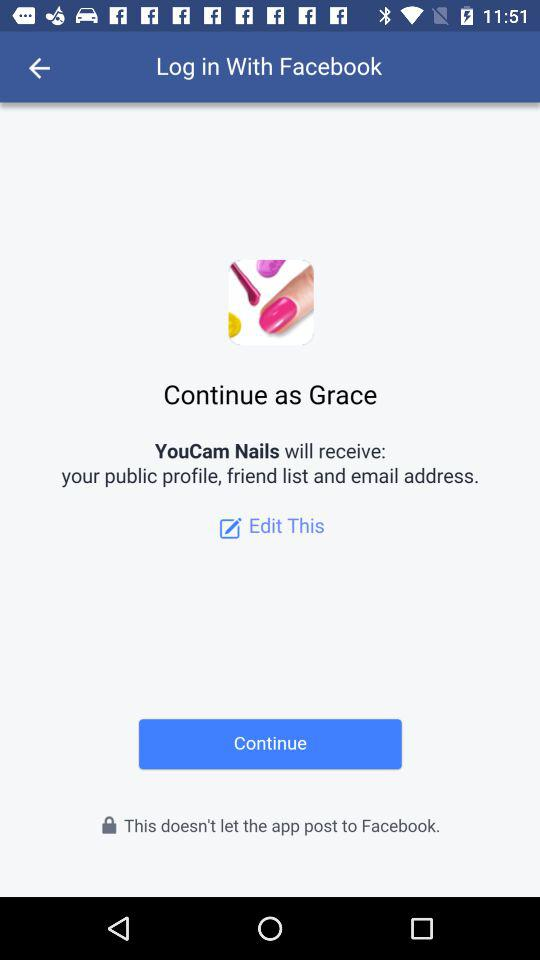What is the user name? The user name is Grace. 